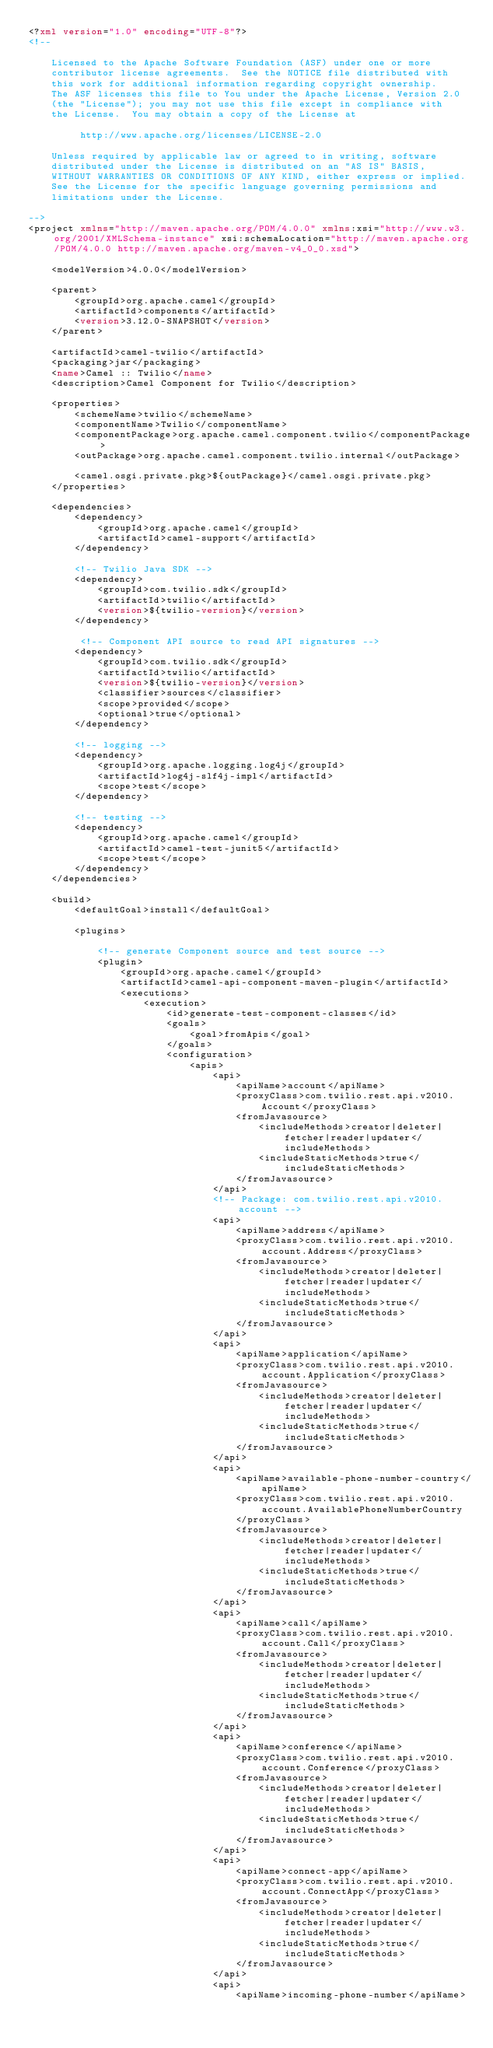Convert code to text. <code><loc_0><loc_0><loc_500><loc_500><_XML_><?xml version="1.0" encoding="UTF-8"?>
<!--

    Licensed to the Apache Software Foundation (ASF) under one or more
    contributor license agreements.  See the NOTICE file distributed with
    this work for additional information regarding copyright ownership.
    The ASF licenses this file to You under the Apache License, Version 2.0
    (the "License"); you may not use this file except in compliance with
    the License.  You may obtain a copy of the License at

         http://www.apache.org/licenses/LICENSE-2.0

    Unless required by applicable law or agreed to in writing, software
    distributed under the License is distributed on an "AS IS" BASIS,
    WITHOUT WARRANTIES OR CONDITIONS OF ANY KIND, either express or implied.
    See the License for the specific language governing permissions and
    limitations under the License.

-->
<project xmlns="http://maven.apache.org/POM/4.0.0" xmlns:xsi="http://www.w3.org/2001/XMLSchema-instance" xsi:schemaLocation="http://maven.apache.org/POM/4.0.0 http://maven.apache.org/maven-v4_0_0.xsd">

    <modelVersion>4.0.0</modelVersion>

    <parent>
        <groupId>org.apache.camel</groupId>
        <artifactId>components</artifactId>
        <version>3.12.0-SNAPSHOT</version>
    </parent>

    <artifactId>camel-twilio</artifactId>
    <packaging>jar</packaging>
    <name>Camel :: Twilio</name>
    <description>Camel Component for Twilio</description>

    <properties>
        <schemeName>twilio</schemeName>
        <componentName>Twilio</componentName>
        <componentPackage>org.apache.camel.component.twilio</componentPackage>
        <outPackage>org.apache.camel.component.twilio.internal</outPackage>

        <camel.osgi.private.pkg>${outPackage}</camel.osgi.private.pkg>
    </properties>

    <dependencies>
        <dependency>
            <groupId>org.apache.camel</groupId>
            <artifactId>camel-support</artifactId>
        </dependency>

        <!-- Twilio Java SDK -->
        <dependency>
            <groupId>com.twilio.sdk</groupId>
            <artifactId>twilio</artifactId>
            <version>${twilio-version}</version>
        </dependency>

         <!-- Component API source to read API signatures -->
        <dependency>
            <groupId>com.twilio.sdk</groupId>
            <artifactId>twilio</artifactId>
            <version>${twilio-version}</version>
            <classifier>sources</classifier>
            <scope>provided</scope>
            <optional>true</optional>
        </dependency>

        <!-- logging -->
        <dependency>
            <groupId>org.apache.logging.log4j</groupId>
            <artifactId>log4j-slf4j-impl</artifactId>
            <scope>test</scope>
        </dependency>

        <!-- testing -->
        <dependency>
            <groupId>org.apache.camel</groupId>
            <artifactId>camel-test-junit5</artifactId>
            <scope>test</scope>
        </dependency>
    </dependencies>

    <build>
        <defaultGoal>install</defaultGoal>

        <plugins>

            <!-- generate Component source and test source -->
            <plugin>
                <groupId>org.apache.camel</groupId>
                <artifactId>camel-api-component-maven-plugin</artifactId>
                <executions>
                    <execution>
                        <id>generate-test-component-classes</id>
                        <goals>
                            <goal>fromApis</goal>
                        </goals>
                        <configuration>
                            <apis>
                                <api>
                                    <apiName>account</apiName>
                                    <proxyClass>com.twilio.rest.api.v2010.Account</proxyClass>
                                    <fromJavasource>
                                        <includeMethods>creator|deleter|fetcher|reader|updater</includeMethods>
                                        <includeStaticMethods>true</includeStaticMethods>
                                    </fromJavasource>
                                </api>
                                <!-- Package: com.twilio.rest.api.v2010.account -->
                                <api>
                                    <apiName>address</apiName>
                                    <proxyClass>com.twilio.rest.api.v2010.account.Address</proxyClass>
                                    <fromJavasource>
                                        <includeMethods>creator|deleter|fetcher|reader|updater</includeMethods>
                                        <includeStaticMethods>true</includeStaticMethods>
                                    </fromJavasource>
                                </api>
                                <api>
                                    <apiName>application</apiName>
                                    <proxyClass>com.twilio.rest.api.v2010.account.Application</proxyClass>
                                    <fromJavasource>
                                        <includeMethods>creator|deleter|fetcher|reader|updater</includeMethods>
                                        <includeStaticMethods>true</includeStaticMethods>
                                    </fromJavasource>
                                </api>
                                <api>
                                    <apiName>available-phone-number-country</apiName>
                                    <proxyClass>com.twilio.rest.api.v2010.account.AvailablePhoneNumberCountry
                                    </proxyClass>
                                    <fromJavasource>
                                        <includeMethods>creator|deleter|fetcher|reader|updater</includeMethods>
                                        <includeStaticMethods>true</includeStaticMethods>
                                    </fromJavasource>
                                </api>
                                <api>
                                    <apiName>call</apiName>
                                    <proxyClass>com.twilio.rest.api.v2010.account.Call</proxyClass>
                                    <fromJavasource>
                                        <includeMethods>creator|deleter|fetcher|reader|updater</includeMethods>
                                        <includeStaticMethods>true</includeStaticMethods>
                                    </fromJavasource>
                                </api>
                                <api>
                                    <apiName>conference</apiName>
                                    <proxyClass>com.twilio.rest.api.v2010.account.Conference</proxyClass>
                                    <fromJavasource>
                                        <includeMethods>creator|deleter|fetcher|reader|updater</includeMethods>
                                        <includeStaticMethods>true</includeStaticMethods>
                                    </fromJavasource>
                                </api>
                                <api>
                                    <apiName>connect-app</apiName>
                                    <proxyClass>com.twilio.rest.api.v2010.account.ConnectApp</proxyClass>
                                    <fromJavasource>
                                        <includeMethods>creator|deleter|fetcher|reader|updater</includeMethods>
                                        <includeStaticMethods>true</includeStaticMethods>
                                    </fromJavasource>
                                </api>
                                <api>
                                    <apiName>incoming-phone-number</apiName></code> 